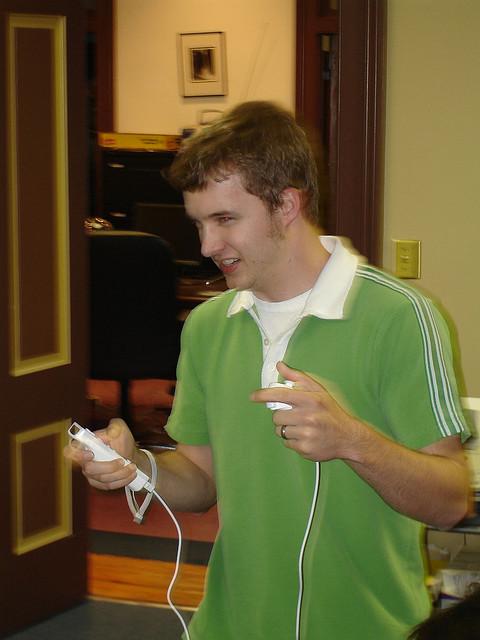What is the person doing?
Write a very short answer. Playing wii. Where is the light switch?
Answer briefly. Wall. What color is his shirt?
Be succinct. Green. 